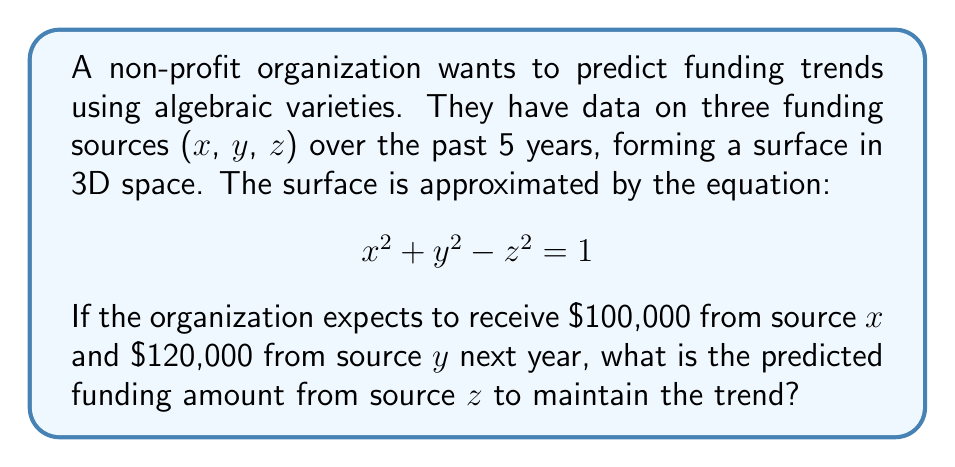Could you help me with this problem? Let's approach this step-by-step:

1) We are given the equation of the algebraic variety (a quadric surface):
   $$ x^2 + y^2 - z^2 = 1 $$

2) We know the values for x and y:
   x = 100,000
   y = 120,000

3) Let's substitute these values into the equation:
   $$ (100,000)^2 + (120,000)^2 - z^2 = 1 $$

4) Simplify:
   $$ 10,000,000,000 + 14,400,000,000 - z^2 = 1 $$
   $$ 24,400,000,000 - z^2 = 1 $$

5) Isolate z^2:
   $$ z^2 = 24,400,000,000 - 1 $$
   $$ z^2 = 24,399,999,999 $$

6) Take the square root of both sides:
   $$ z = \sqrt{24,399,999,999} $$

7) Calculate:
   $$ z \approx 156,205.24 $$

Therefore, to maintain the funding trend, the predicted amount from source z should be approximately $156,205.24.
Answer: $156,205.24 